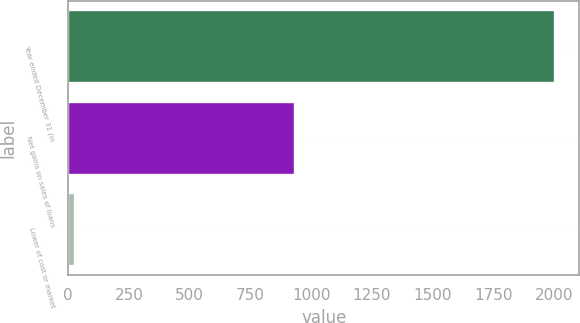<chart> <loc_0><loc_0><loc_500><loc_500><bar_chart><fcel>Year ended December 31 (in<fcel>Net gains on sales of loans<fcel>Lower of cost or market<nl><fcel>2003<fcel>933<fcel>26<nl></chart> 